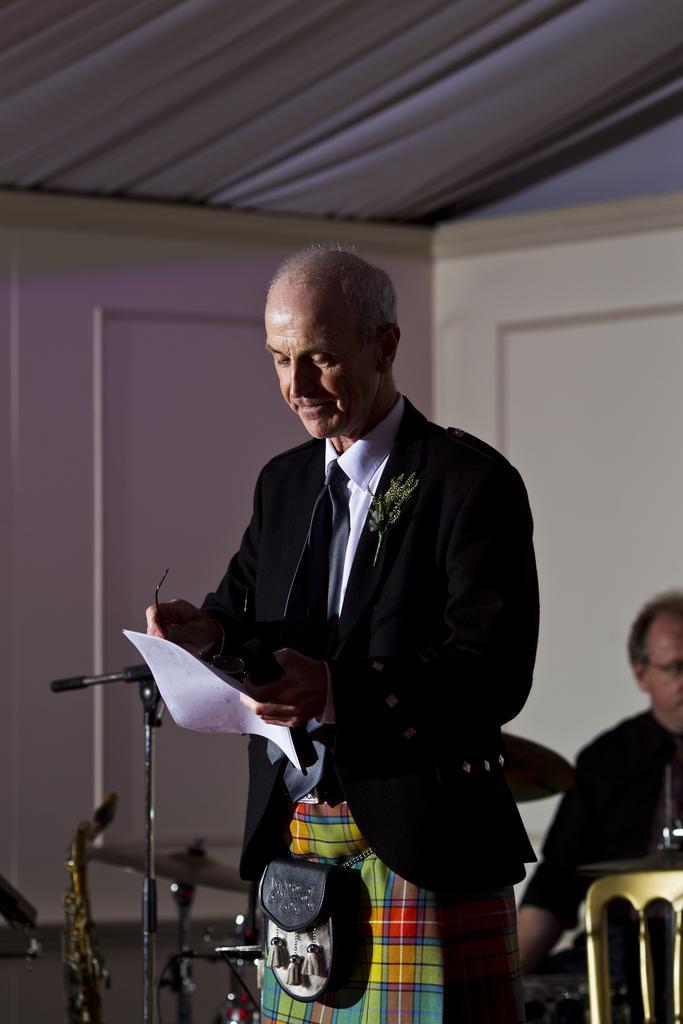In one or two sentences, can you explain what this image depicts? In this image in the center there is one man who is standing and he is holding a paper and mike in his hands, and on the right side there is one person. And on the left side there are some drums, and on the top there is a ceiling and in the center there is a wall. 